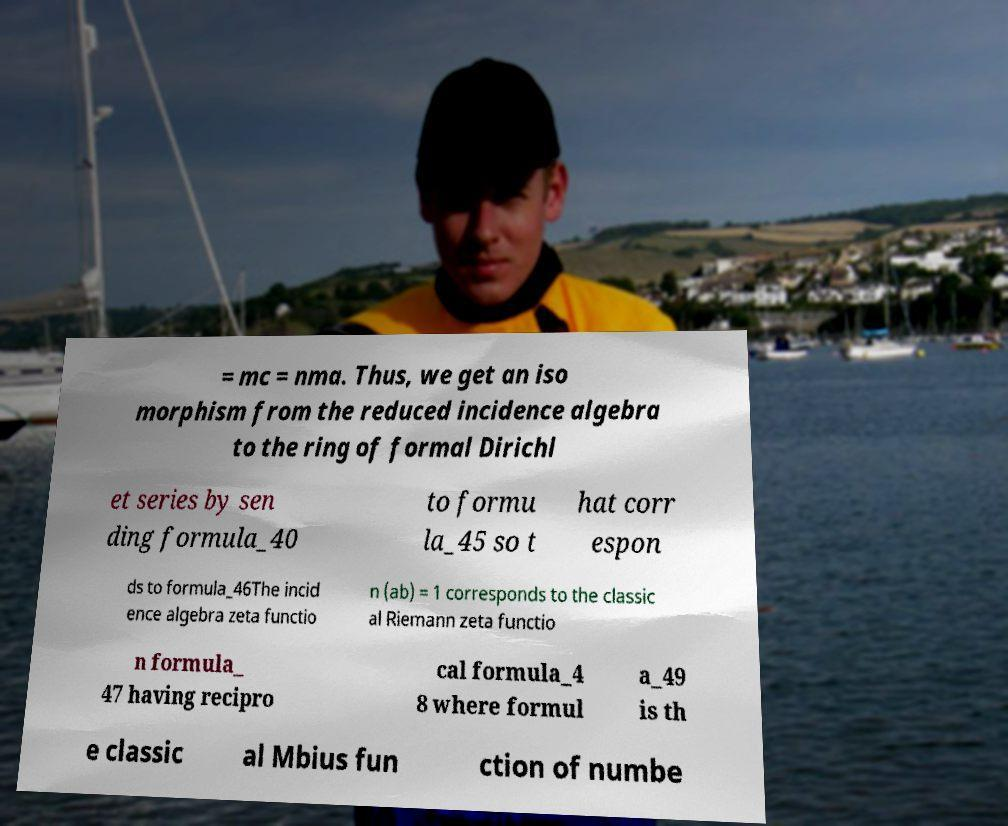Please read and relay the text visible in this image. What does it say? = mc = nma. Thus, we get an iso morphism from the reduced incidence algebra to the ring of formal Dirichl et series by sen ding formula_40 to formu la_45 so t hat corr espon ds to formula_46The incid ence algebra zeta functio n (ab) = 1 corresponds to the classic al Riemann zeta functio n formula_ 47 having recipro cal formula_4 8 where formul a_49 is th e classic al Mbius fun ction of numbe 